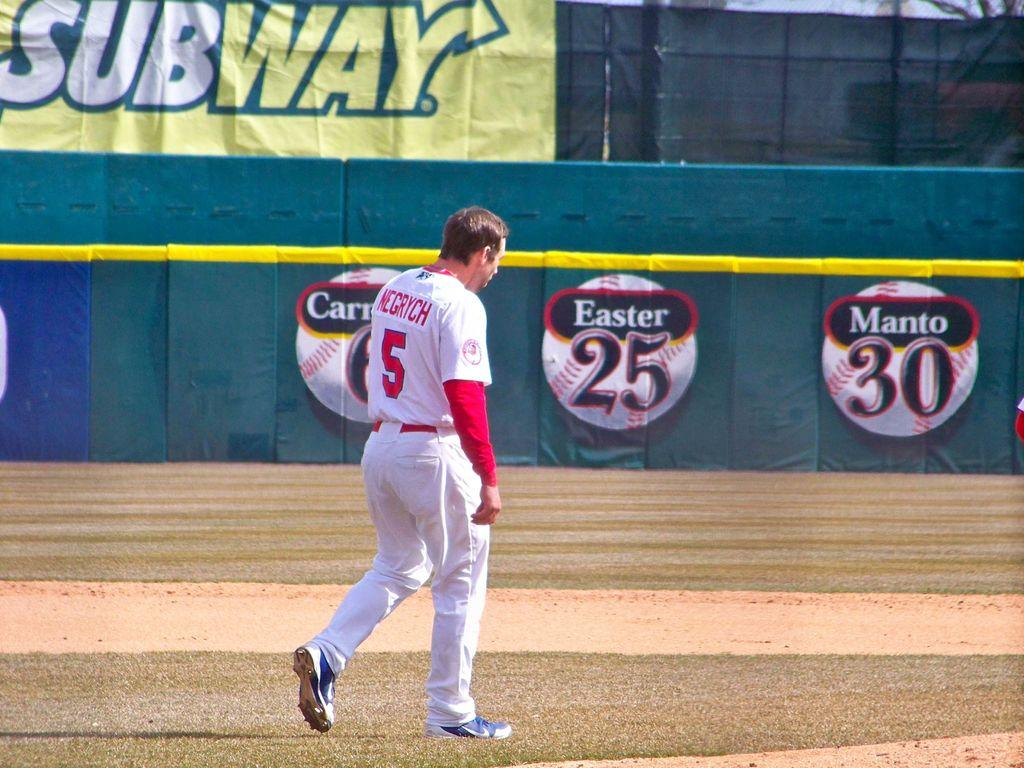<image>
Present a compact description of the photo's key features. Player number 5 is named Negrych and he walks toward the outfield. 